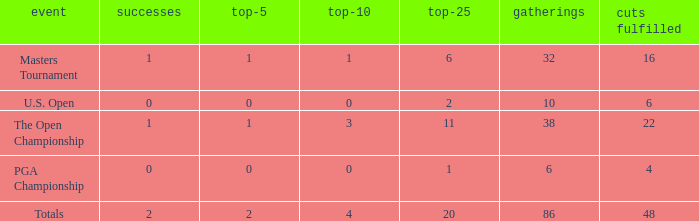Tell me the total number of top 25 for wins less than 1 and cuts made of 22 0.0. 